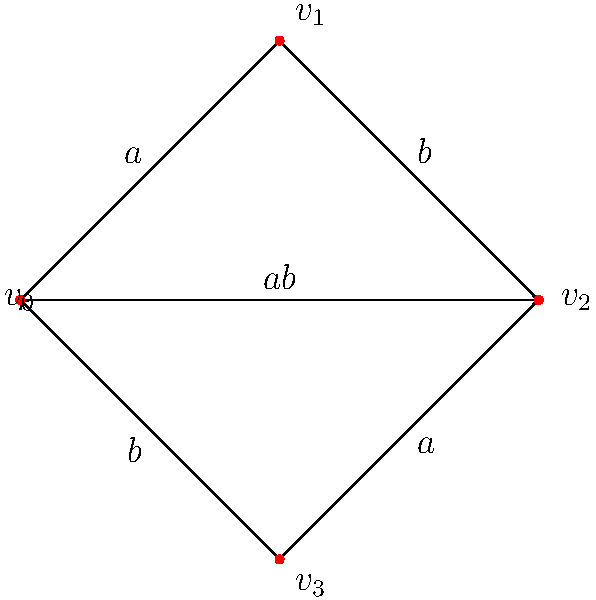In your data clustering algorithm analysis, you encounter a Cayley graph of a group $G$ with two generators $a$ and $b$. The graph is shown above. What is the order of the group $G$, and what is the algebraic structure of $G$? To determine the order and structure of the group $G$, let's analyze the Cayley graph step-by-step:

1. Count the vertices: The graph has 4 vertices, so the order of the group $G$ is 4.

2. Identify the generators: We have two generators, $a$ and $b$.

3. Analyze the cycles:
   - Following $a$ twice returns to the starting point: $a^2 = e$ (identity)
   - Following $b$ twice returns to the starting point: $b^2 = e$
   - Following $abab$ returns to the starting point: $(ab)^2 = e$

4. These relations suggest that $G$ is isomorphic to the Klein four-group $V_4$ or $\mathbb{Z}_2 \times \mathbb{Z}_2$.

5. Verify the group table:
   $$\begin{array}{c|cccc}
   & e & a & b & ab \\
   \hline
   e & e & a & b & ab \\
   a & a & e & ab & b \\
   b & b & ab & e & a \\
   ab & ab & b & a & e
   \end{array}$$

6. This confirms that $G \cong V_4 \cong \mathbb{Z}_2 \times \mathbb{Z}_2$.

Therefore, the group $G$ has order 4 and is isomorphic to the Klein four-group.
Answer: Order 4, $G \cong V_4 \cong \mathbb{Z}_2 \times \mathbb{Z}_2$ 